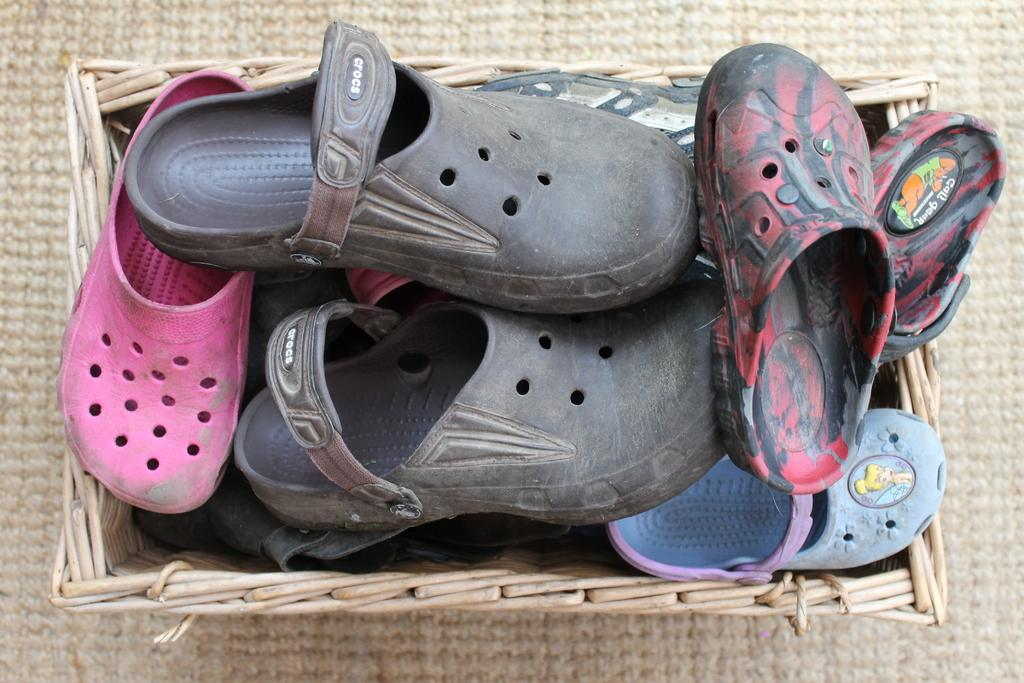What type of object is present in the image? There is footwear in the image. Where are the footwear located? The footwear is in a basket. How many balls are present in the image? There are no balls visible in the image; it only features footwear in a basket. What is the wealth status of the person who owns the footwear in the image? There is no information about the wealth status of the person who owns the footwear in the image. 